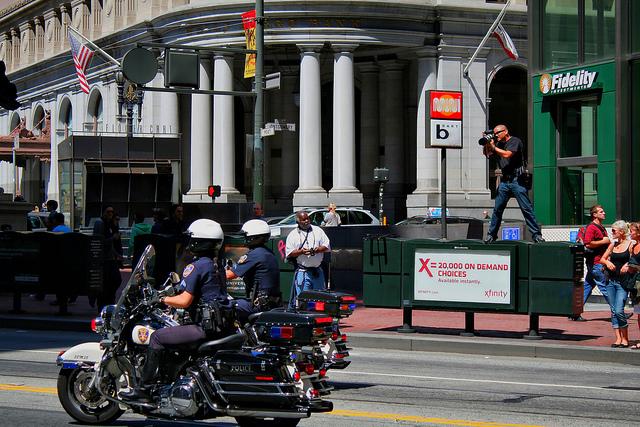Are the police in the motorcycles?
Short answer required. Yes. Where is this?
Concise answer only. City street. What is the cameraman who is standing near the pole with the b, taking a picture of?
Short answer required. Motorcycle cops. 